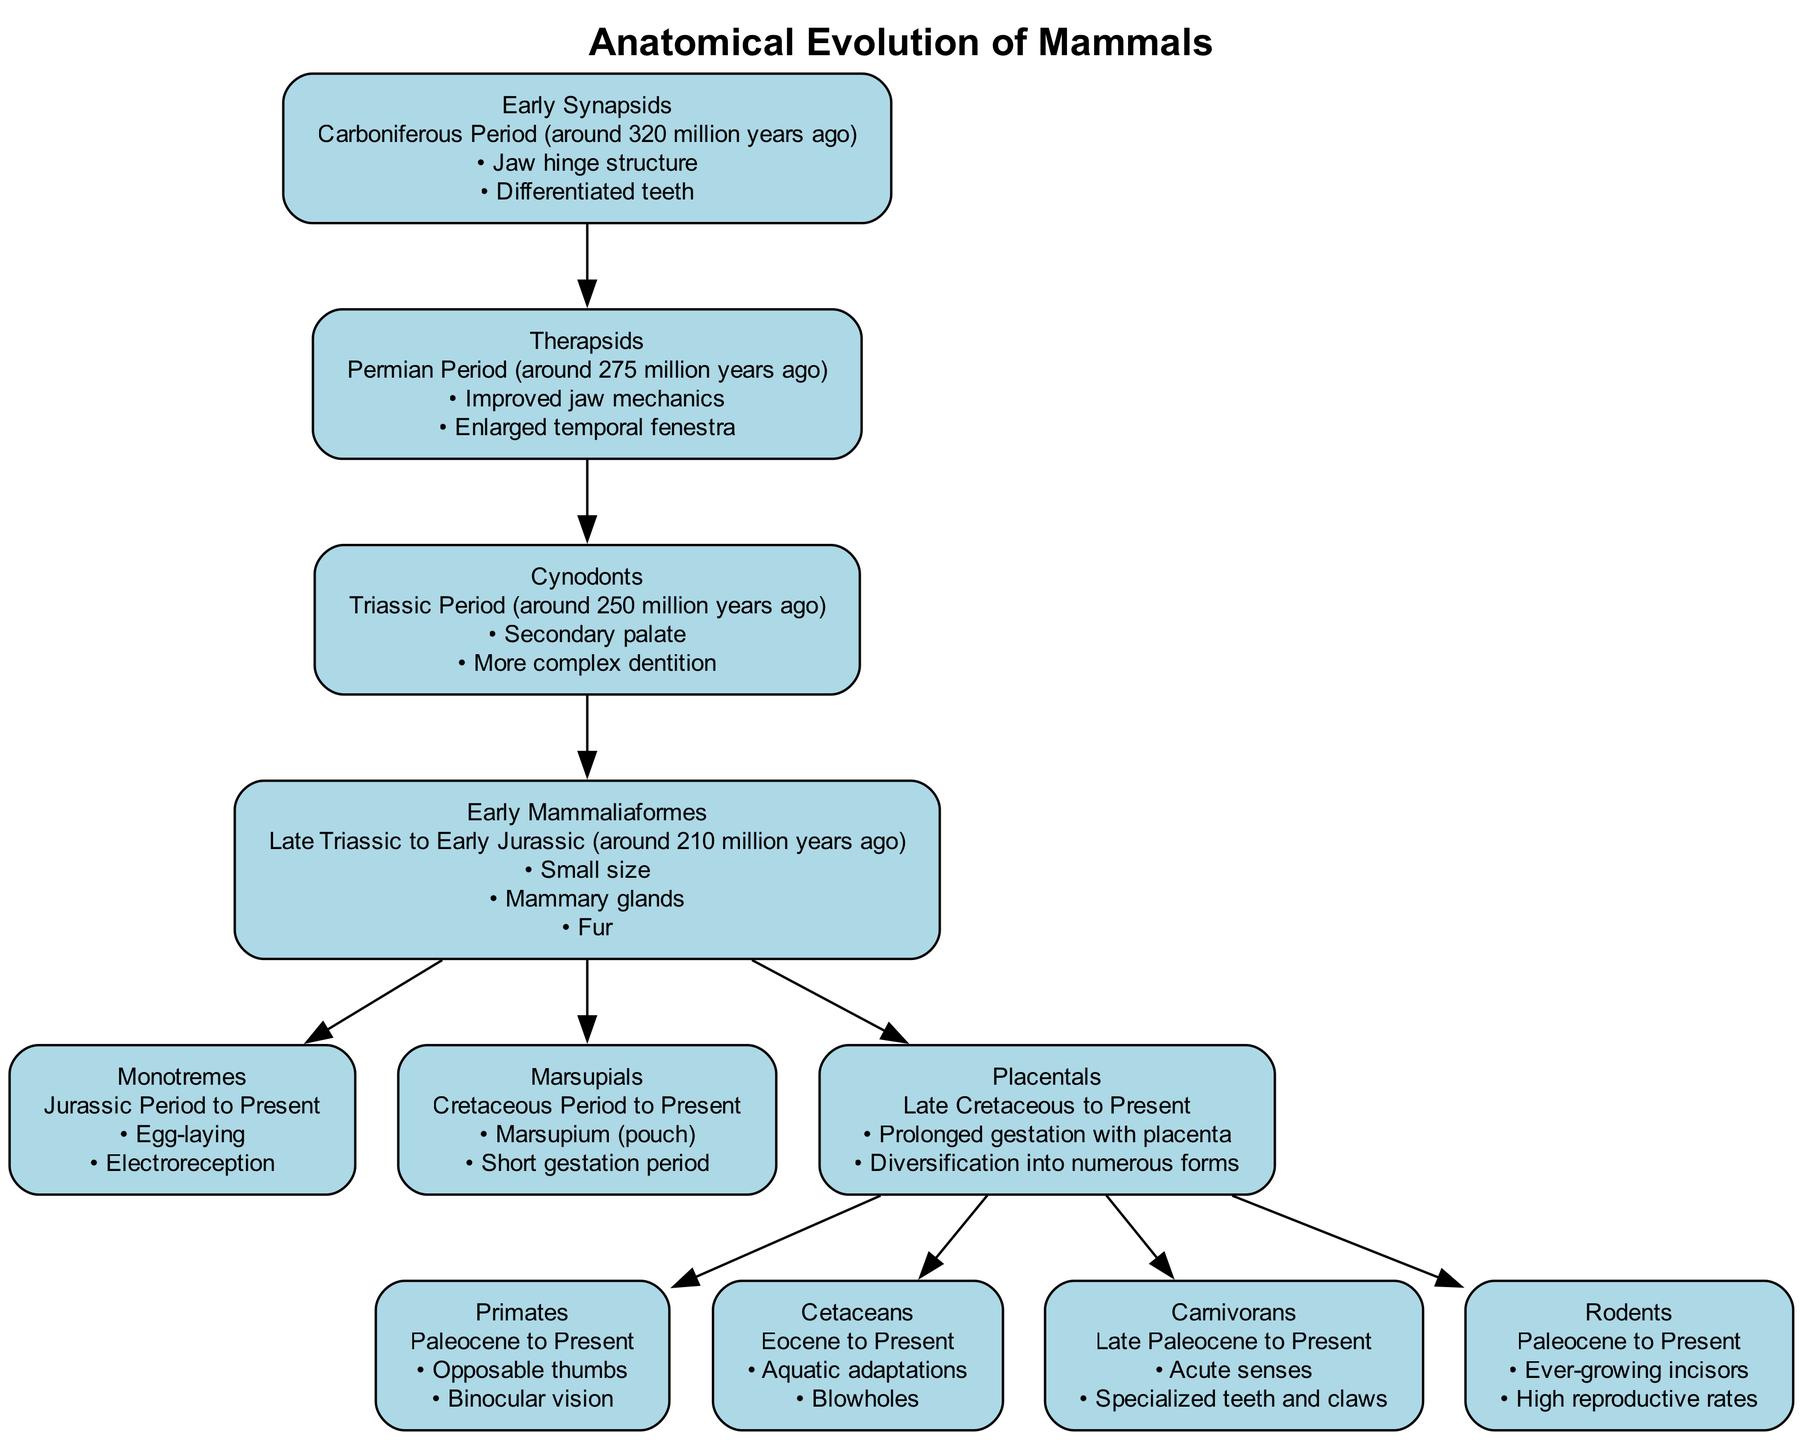What is the period of Early Synapsids? Early Synapsids are from the Carboniferous Period, which is stated in the description of that node.
Answer: Carboniferous Period How many key innovations are listed for Marsupials? The Marsupials node lists two key innovations: Marsupium (pouch) and Short gestation period, making it a total of two innovations.
Answer: 2 Which group is directly descended from Early Mammaliaformes? The connections show that both Monotremes, Marsupials, and Placentals descend from Early Mammaliaformes, indicating multiple descendants. However, "Monotremes" is the first one listed that directly branches from it.
Answer: Monotremes What anatomical innovation is associated with Cetaceans? The key innovations for Cetaceans include Aquatic adaptations and Blowholes, indicating their specialized adaptations for life in water.
Answer: Aquatic adaptations How many nodes are related to Placentals directly? Placentals have four direct connections to Primates, Cetaceans, Carnivorans, and Rodents, meaning there are four nodes related to Placentals.
Answer: 4 What is the relationship between Therapsids and Cynodonts? Therapsids are directly connected to Cynodonts, as shown by the edge that indicates Therapsids are ancestors of Cynodonts.
Answer: Direct descent Which group represents the most recent anatomical innovations? In terms of time, Rodents are part of the Paleocene to Present period and are included in the most recent branch of Placentals. This indicates they likely represent newer adaptations than the earlier nodes.
Answer: Rodents What is one key innovation of Carnivorans? The Carnivorans node highlights Acute senses as one of their key innovations, pointing out their evolutionary adaptation.
Answer: Acute senses What period do Monotremes span from? The node for Monotremes states that they span from the Jurassic Period to Present, clearly showing their long evolutionary history.
Answer: Jurassic Period to Present 